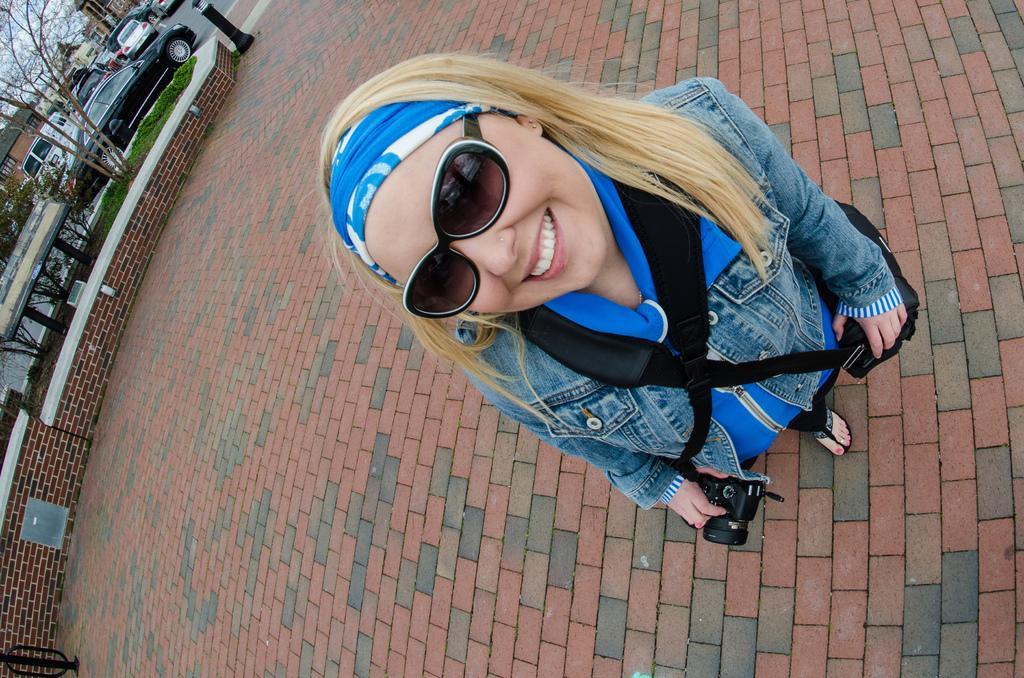Can you describe this image briefly? In this image we can see the woman posing to the picture. And holding a bag and a Camera. And left side we can see roads, building and trees, lights are seen. And we can Clouds to the sky 